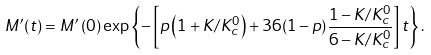<formula> <loc_0><loc_0><loc_500><loc_500>M ^ { \prime } ( t ) = M ^ { \prime } \left ( 0 \right ) \exp \left \{ - \left [ p \left ( 1 + K / K _ { c } ^ { 0 } \right ) + 3 6 ( 1 - p ) \frac { 1 - K / K _ { c } ^ { 0 } } { 6 - K / K _ { c } ^ { 0 } } \right ] t \right \} .</formula> 